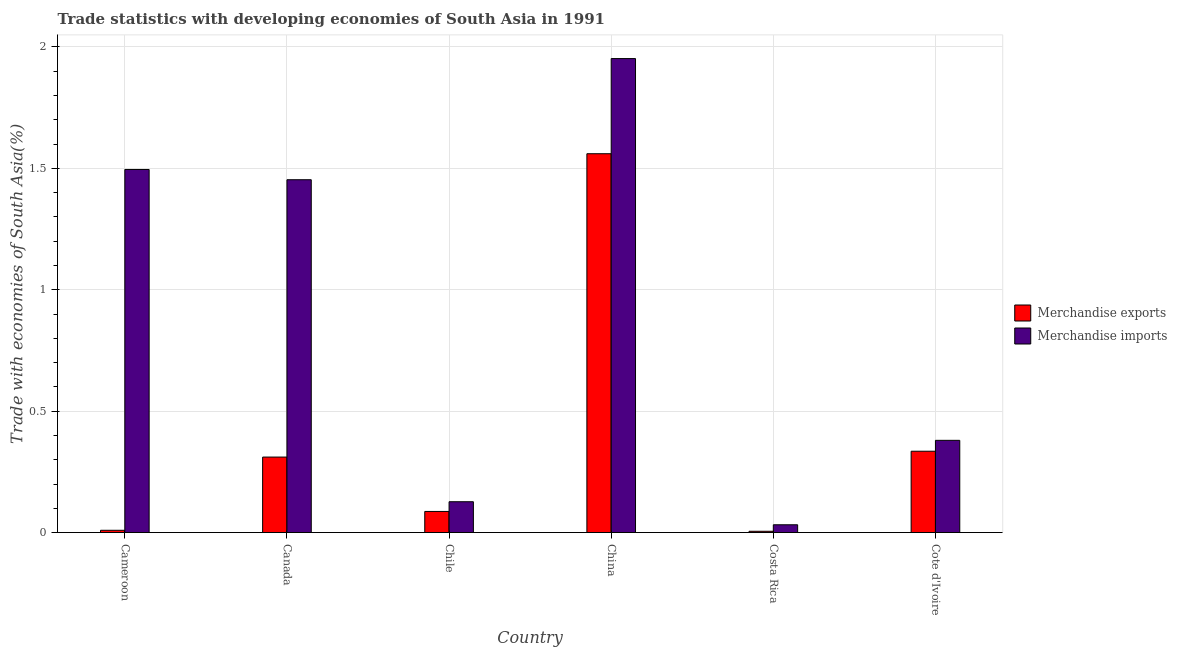How many bars are there on the 3rd tick from the left?
Your answer should be very brief. 2. What is the label of the 1st group of bars from the left?
Offer a terse response. Cameroon. What is the merchandise imports in China?
Ensure brevity in your answer.  1.95. Across all countries, what is the maximum merchandise imports?
Offer a very short reply. 1.95. Across all countries, what is the minimum merchandise exports?
Make the answer very short. 0.01. In which country was the merchandise exports maximum?
Provide a short and direct response. China. What is the total merchandise imports in the graph?
Your response must be concise. 5.44. What is the difference between the merchandise imports in Chile and that in China?
Provide a short and direct response. -1.83. What is the difference between the merchandise exports in Canada and the merchandise imports in Chile?
Give a very brief answer. 0.18. What is the average merchandise imports per country?
Provide a short and direct response. 0.91. What is the difference between the merchandise exports and merchandise imports in Cameroon?
Provide a succinct answer. -1.49. In how many countries, is the merchandise imports greater than 1.4 %?
Offer a terse response. 3. What is the ratio of the merchandise imports in Cameroon to that in Cote d'Ivoire?
Keep it short and to the point. 3.94. What is the difference between the highest and the second highest merchandise imports?
Keep it short and to the point. 0.46. What is the difference between the highest and the lowest merchandise exports?
Offer a very short reply. 1.55. In how many countries, is the merchandise imports greater than the average merchandise imports taken over all countries?
Keep it short and to the point. 3. What does the 2nd bar from the left in Costa Rica represents?
Keep it short and to the point. Merchandise imports. Are all the bars in the graph horizontal?
Keep it short and to the point. No. How many countries are there in the graph?
Provide a succinct answer. 6. Does the graph contain any zero values?
Ensure brevity in your answer.  No. How many legend labels are there?
Provide a succinct answer. 2. What is the title of the graph?
Provide a short and direct response. Trade statistics with developing economies of South Asia in 1991. Does "Domestic liabilities" appear as one of the legend labels in the graph?
Provide a succinct answer. No. What is the label or title of the X-axis?
Provide a short and direct response. Country. What is the label or title of the Y-axis?
Ensure brevity in your answer.  Trade with economies of South Asia(%). What is the Trade with economies of South Asia(%) in Merchandise exports in Cameroon?
Make the answer very short. 0.01. What is the Trade with economies of South Asia(%) of Merchandise imports in Cameroon?
Offer a terse response. 1.5. What is the Trade with economies of South Asia(%) of Merchandise exports in Canada?
Your answer should be very brief. 0.31. What is the Trade with economies of South Asia(%) of Merchandise imports in Canada?
Provide a succinct answer. 1.45. What is the Trade with economies of South Asia(%) in Merchandise exports in Chile?
Offer a terse response. 0.09. What is the Trade with economies of South Asia(%) in Merchandise imports in Chile?
Make the answer very short. 0.13. What is the Trade with economies of South Asia(%) in Merchandise exports in China?
Ensure brevity in your answer.  1.56. What is the Trade with economies of South Asia(%) in Merchandise imports in China?
Your answer should be very brief. 1.95. What is the Trade with economies of South Asia(%) of Merchandise exports in Costa Rica?
Offer a terse response. 0.01. What is the Trade with economies of South Asia(%) of Merchandise imports in Costa Rica?
Provide a short and direct response. 0.03. What is the Trade with economies of South Asia(%) of Merchandise exports in Cote d'Ivoire?
Ensure brevity in your answer.  0.34. What is the Trade with economies of South Asia(%) of Merchandise imports in Cote d'Ivoire?
Your response must be concise. 0.38. Across all countries, what is the maximum Trade with economies of South Asia(%) of Merchandise exports?
Give a very brief answer. 1.56. Across all countries, what is the maximum Trade with economies of South Asia(%) in Merchandise imports?
Keep it short and to the point. 1.95. Across all countries, what is the minimum Trade with economies of South Asia(%) in Merchandise exports?
Provide a short and direct response. 0.01. Across all countries, what is the minimum Trade with economies of South Asia(%) in Merchandise imports?
Your response must be concise. 0.03. What is the total Trade with economies of South Asia(%) of Merchandise exports in the graph?
Provide a short and direct response. 2.31. What is the total Trade with economies of South Asia(%) of Merchandise imports in the graph?
Your answer should be very brief. 5.44. What is the difference between the Trade with economies of South Asia(%) in Merchandise exports in Cameroon and that in Canada?
Your answer should be compact. -0.3. What is the difference between the Trade with economies of South Asia(%) of Merchandise imports in Cameroon and that in Canada?
Your response must be concise. 0.04. What is the difference between the Trade with economies of South Asia(%) of Merchandise exports in Cameroon and that in Chile?
Your response must be concise. -0.08. What is the difference between the Trade with economies of South Asia(%) of Merchandise imports in Cameroon and that in Chile?
Offer a very short reply. 1.37. What is the difference between the Trade with economies of South Asia(%) in Merchandise exports in Cameroon and that in China?
Your answer should be compact. -1.55. What is the difference between the Trade with economies of South Asia(%) in Merchandise imports in Cameroon and that in China?
Provide a succinct answer. -0.46. What is the difference between the Trade with economies of South Asia(%) in Merchandise exports in Cameroon and that in Costa Rica?
Offer a terse response. 0. What is the difference between the Trade with economies of South Asia(%) of Merchandise imports in Cameroon and that in Costa Rica?
Provide a succinct answer. 1.46. What is the difference between the Trade with economies of South Asia(%) of Merchandise exports in Cameroon and that in Cote d'Ivoire?
Keep it short and to the point. -0.33. What is the difference between the Trade with economies of South Asia(%) in Merchandise imports in Cameroon and that in Cote d'Ivoire?
Keep it short and to the point. 1.12. What is the difference between the Trade with economies of South Asia(%) in Merchandise exports in Canada and that in Chile?
Your response must be concise. 0.22. What is the difference between the Trade with economies of South Asia(%) of Merchandise imports in Canada and that in Chile?
Offer a terse response. 1.33. What is the difference between the Trade with economies of South Asia(%) of Merchandise exports in Canada and that in China?
Your answer should be compact. -1.25. What is the difference between the Trade with economies of South Asia(%) in Merchandise imports in Canada and that in China?
Your response must be concise. -0.5. What is the difference between the Trade with economies of South Asia(%) of Merchandise exports in Canada and that in Costa Rica?
Your answer should be very brief. 0.31. What is the difference between the Trade with economies of South Asia(%) in Merchandise imports in Canada and that in Costa Rica?
Your answer should be compact. 1.42. What is the difference between the Trade with economies of South Asia(%) in Merchandise exports in Canada and that in Cote d'Ivoire?
Provide a short and direct response. -0.02. What is the difference between the Trade with economies of South Asia(%) in Merchandise imports in Canada and that in Cote d'Ivoire?
Offer a terse response. 1.07. What is the difference between the Trade with economies of South Asia(%) of Merchandise exports in Chile and that in China?
Your response must be concise. -1.47. What is the difference between the Trade with economies of South Asia(%) of Merchandise imports in Chile and that in China?
Keep it short and to the point. -1.82. What is the difference between the Trade with economies of South Asia(%) of Merchandise exports in Chile and that in Costa Rica?
Provide a short and direct response. 0.08. What is the difference between the Trade with economies of South Asia(%) in Merchandise imports in Chile and that in Costa Rica?
Your answer should be very brief. 0.09. What is the difference between the Trade with economies of South Asia(%) in Merchandise exports in Chile and that in Cote d'Ivoire?
Offer a very short reply. -0.25. What is the difference between the Trade with economies of South Asia(%) in Merchandise imports in Chile and that in Cote d'Ivoire?
Your answer should be very brief. -0.25. What is the difference between the Trade with economies of South Asia(%) of Merchandise exports in China and that in Costa Rica?
Provide a succinct answer. 1.55. What is the difference between the Trade with economies of South Asia(%) of Merchandise imports in China and that in Costa Rica?
Provide a succinct answer. 1.92. What is the difference between the Trade with economies of South Asia(%) of Merchandise exports in China and that in Cote d'Ivoire?
Ensure brevity in your answer.  1.23. What is the difference between the Trade with economies of South Asia(%) in Merchandise imports in China and that in Cote d'Ivoire?
Provide a succinct answer. 1.57. What is the difference between the Trade with economies of South Asia(%) of Merchandise exports in Costa Rica and that in Cote d'Ivoire?
Your answer should be compact. -0.33. What is the difference between the Trade with economies of South Asia(%) of Merchandise imports in Costa Rica and that in Cote d'Ivoire?
Your response must be concise. -0.35. What is the difference between the Trade with economies of South Asia(%) in Merchandise exports in Cameroon and the Trade with economies of South Asia(%) in Merchandise imports in Canada?
Offer a very short reply. -1.44. What is the difference between the Trade with economies of South Asia(%) of Merchandise exports in Cameroon and the Trade with economies of South Asia(%) of Merchandise imports in Chile?
Provide a succinct answer. -0.12. What is the difference between the Trade with economies of South Asia(%) in Merchandise exports in Cameroon and the Trade with economies of South Asia(%) in Merchandise imports in China?
Ensure brevity in your answer.  -1.94. What is the difference between the Trade with economies of South Asia(%) of Merchandise exports in Cameroon and the Trade with economies of South Asia(%) of Merchandise imports in Costa Rica?
Provide a short and direct response. -0.02. What is the difference between the Trade with economies of South Asia(%) of Merchandise exports in Cameroon and the Trade with economies of South Asia(%) of Merchandise imports in Cote d'Ivoire?
Make the answer very short. -0.37. What is the difference between the Trade with economies of South Asia(%) of Merchandise exports in Canada and the Trade with economies of South Asia(%) of Merchandise imports in Chile?
Provide a short and direct response. 0.18. What is the difference between the Trade with economies of South Asia(%) in Merchandise exports in Canada and the Trade with economies of South Asia(%) in Merchandise imports in China?
Offer a terse response. -1.64. What is the difference between the Trade with economies of South Asia(%) in Merchandise exports in Canada and the Trade with economies of South Asia(%) in Merchandise imports in Costa Rica?
Offer a very short reply. 0.28. What is the difference between the Trade with economies of South Asia(%) of Merchandise exports in Canada and the Trade with economies of South Asia(%) of Merchandise imports in Cote d'Ivoire?
Your answer should be compact. -0.07. What is the difference between the Trade with economies of South Asia(%) in Merchandise exports in Chile and the Trade with economies of South Asia(%) in Merchandise imports in China?
Keep it short and to the point. -1.87. What is the difference between the Trade with economies of South Asia(%) in Merchandise exports in Chile and the Trade with economies of South Asia(%) in Merchandise imports in Costa Rica?
Your answer should be compact. 0.05. What is the difference between the Trade with economies of South Asia(%) in Merchandise exports in Chile and the Trade with economies of South Asia(%) in Merchandise imports in Cote d'Ivoire?
Keep it short and to the point. -0.29. What is the difference between the Trade with economies of South Asia(%) in Merchandise exports in China and the Trade with economies of South Asia(%) in Merchandise imports in Costa Rica?
Provide a short and direct response. 1.53. What is the difference between the Trade with economies of South Asia(%) in Merchandise exports in China and the Trade with economies of South Asia(%) in Merchandise imports in Cote d'Ivoire?
Provide a short and direct response. 1.18. What is the difference between the Trade with economies of South Asia(%) in Merchandise exports in Costa Rica and the Trade with economies of South Asia(%) in Merchandise imports in Cote d'Ivoire?
Ensure brevity in your answer.  -0.37. What is the average Trade with economies of South Asia(%) in Merchandise exports per country?
Your answer should be compact. 0.38. What is the average Trade with economies of South Asia(%) in Merchandise imports per country?
Give a very brief answer. 0.91. What is the difference between the Trade with economies of South Asia(%) in Merchandise exports and Trade with economies of South Asia(%) in Merchandise imports in Cameroon?
Offer a very short reply. -1.49. What is the difference between the Trade with economies of South Asia(%) in Merchandise exports and Trade with economies of South Asia(%) in Merchandise imports in Canada?
Offer a very short reply. -1.14. What is the difference between the Trade with economies of South Asia(%) in Merchandise exports and Trade with economies of South Asia(%) in Merchandise imports in Chile?
Your answer should be very brief. -0.04. What is the difference between the Trade with economies of South Asia(%) of Merchandise exports and Trade with economies of South Asia(%) of Merchandise imports in China?
Your response must be concise. -0.39. What is the difference between the Trade with economies of South Asia(%) of Merchandise exports and Trade with economies of South Asia(%) of Merchandise imports in Costa Rica?
Make the answer very short. -0.03. What is the difference between the Trade with economies of South Asia(%) in Merchandise exports and Trade with economies of South Asia(%) in Merchandise imports in Cote d'Ivoire?
Make the answer very short. -0.04. What is the ratio of the Trade with economies of South Asia(%) of Merchandise exports in Cameroon to that in Canada?
Provide a succinct answer. 0.03. What is the ratio of the Trade with economies of South Asia(%) in Merchandise imports in Cameroon to that in Canada?
Give a very brief answer. 1.03. What is the ratio of the Trade with economies of South Asia(%) of Merchandise exports in Cameroon to that in Chile?
Offer a terse response. 0.11. What is the ratio of the Trade with economies of South Asia(%) in Merchandise imports in Cameroon to that in Chile?
Your answer should be very brief. 11.77. What is the ratio of the Trade with economies of South Asia(%) in Merchandise exports in Cameroon to that in China?
Give a very brief answer. 0.01. What is the ratio of the Trade with economies of South Asia(%) in Merchandise imports in Cameroon to that in China?
Offer a terse response. 0.77. What is the ratio of the Trade with economies of South Asia(%) in Merchandise exports in Cameroon to that in Costa Rica?
Ensure brevity in your answer.  1.74. What is the ratio of the Trade with economies of South Asia(%) in Merchandise imports in Cameroon to that in Costa Rica?
Offer a very short reply. 46.43. What is the ratio of the Trade with economies of South Asia(%) of Merchandise exports in Cameroon to that in Cote d'Ivoire?
Offer a very short reply. 0.03. What is the ratio of the Trade with economies of South Asia(%) of Merchandise imports in Cameroon to that in Cote d'Ivoire?
Your answer should be compact. 3.94. What is the ratio of the Trade with economies of South Asia(%) of Merchandise exports in Canada to that in Chile?
Offer a very short reply. 3.57. What is the ratio of the Trade with economies of South Asia(%) of Merchandise imports in Canada to that in Chile?
Keep it short and to the point. 11.43. What is the ratio of the Trade with economies of South Asia(%) in Merchandise exports in Canada to that in China?
Offer a very short reply. 0.2. What is the ratio of the Trade with economies of South Asia(%) in Merchandise imports in Canada to that in China?
Give a very brief answer. 0.74. What is the ratio of the Trade with economies of South Asia(%) of Merchandise exports in Canada to that in Costa Rica?
Ensure brevity in your answer.  57.05. What is the ratio of the Trade with economies of South Asia(%) in Merchandise imports in Canada to that in Costa Rica?
Your response must be concise. 45.12. What is the ratio of the Trade with economies of South Asia(%) in Merchandise exports in Canada to that in Cote d'Ivoire?
Your answer should be compact. 0.93. What is the ratio of the Trade with economies of South Asia(%) in Merchandise imports in Canada to that in Cote d'Ivoire?
Ensure brevity in your answer.  3.83. What is the ratio of the Trade with economies of South Asia(%) in Merchandise exports in Chile to that in China?
Offer a terse response. 0.06. What is the ratio of the Trade with economies of South Asia(%) of Merchandise imports in Chile to that in China?
Provide a succinct answer. 0.07. What is the ratio of the Trade with economies of South Asia(%) in Merchandise exports in Chile to that in Costa Rica?
Provide a succinct answer. 15.97. What is the ratio of the Trade with economies of South Asia(%) in Merchandise imports in Chile to that in Costa Rica?
Offer a very short reply. 3.95. What is the ratio of the Trade with economies of South Asia(%) of Merchandise exports in Chile to that in Cote d'Ivoire?
Provide a short and direct response. 0.26. What is the ratio of the Trade with economies of South Asia(%) in Merchandise imports in Chile to that in Cote d'Ivoire?
Your response must be concise. 0.33. What is the ratio of the Trade with economies of South Asia(%) of Merchandise exports in China to that in Costa Rica?
Make the answer very short. 286.17. What is the ratio of the Trade with economies of South Asia(%) of Merchandise imports in China to that in Costa Rica?
Offer a terse response. 60.61. What is the ratio of the Trade with economies of South Asia(%) of Merchandise exports in China to that in Cote d'Ivoire?
Give a very brief answer. 4.66. What is the ratio of the Trade with economies of South Asia(%) of Merchandise imports in China to that in Cote d'Ivoire?
Offer a very short reply. 5.14. What is the ratio of the Trade with economies of South Asia(%) of Merchandise exports in Costa Rica to that in Cote d'Ivoire?
Offer a very short reply. 0.02. What is the ratio of the Trade with economies of South Asia(%) in Merchandise imports in Costa Rica to that in Cote d'Ivoire?
Give a very brief answer. 0.08. What is the difference between the highest and the second highest Trade with economies of South Asia(%) in Merchandise exports?
Keep it short and to the point. 1.23. What is the difference between the highest and the second highest Trade with economies of South Asia(%) in Merchandise imports?
Offer a terse response. 0.46. What is the difference between the highest and the lowest Trade with economies of South Asia(%) of Merchandise exports?
Give a very brief answer. 1.55. What is the difference between the highest and the lowest Trade with economies of South Asia(%) of Merchandise imports?
Make the answer very short. 1.92. 